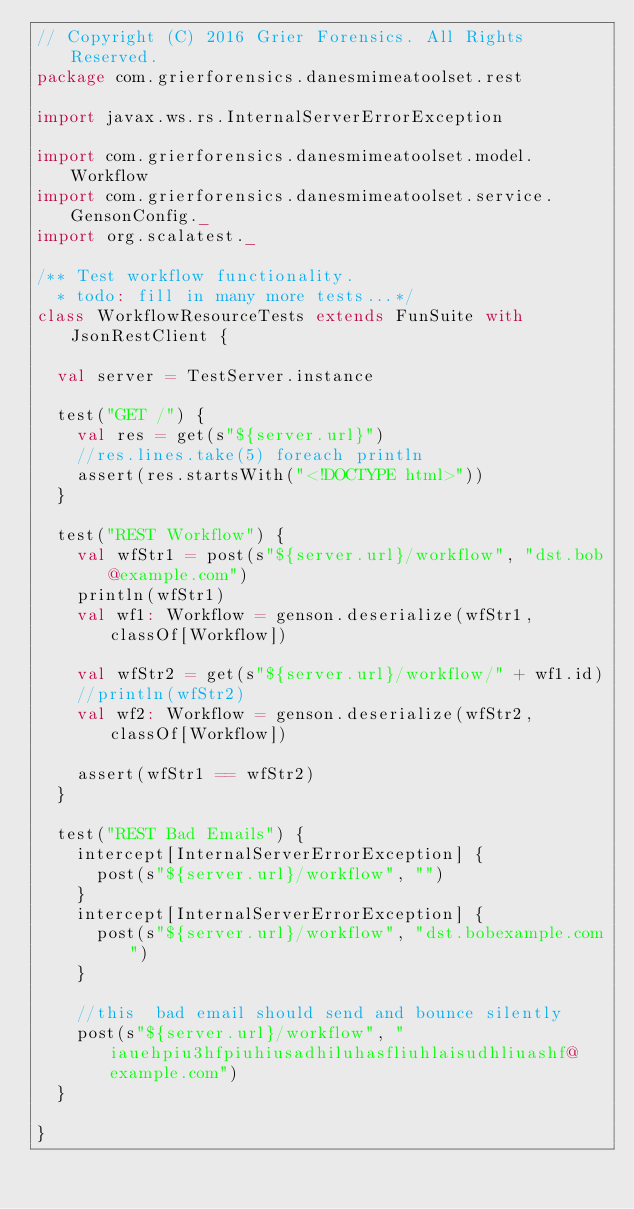<code> <loc_0><loc_0><loc_500><loc_500><_Scala_>// Copyright (C) 2016 Grier Forensics. All Rights Reserved.
package com.grierforensics.danesmimeatoolset.rest

import javax.ws.rs.InternalServerErrorException

import com.grierforensics.danesmimeatoolset.model.Workflow
import com.grierforensics.danesmimeatoolset.service.GensonConfig._
import org.scalatest._

/** Test workflow functionality.
  * todo: fill in many more tests...*/
class WorkflowResourceTests extends FunSuite with JsonRestClient {

  val server = TestServer.instance

  test("GET /") {
    val res = get(s"${server.url}")
    //res.lines.take(5) foreach println
    assert(res.startsWith("<!DOCTYPE html>"))
  }

  test("REST Workflow") {
    val wfStr1 = post(s"${server.url}/workflow", "dst.bob@example.com")
    println(wfStr1)
    val wf1: Workflow = genson.deserialize(wfStr1, classOf[Workflow])

    val wfStr2 = get(s"${server.url}/workflow/" + wf1.id)
    //println(wfStr2)
    val wf2: Workflow = genson.deserialize(wfStr2, classOf[Workflow])

    assert(wfStr1 == wfStr2)
  }

  test("REST Bad Emails") {
    intercept[InternalServerErrorException] {
      post(s"${server.url}/workflow", "")
    }
    intercept[InternalServerErrorException] {
      post(s"${server.url}/workflow", "dst.bobexample.com")
    }

    //this  bad email should send and bounce silently
    post(s"${server.url}/workflow", "iauehpiu3hfpiuhiusadhiluhasfliuhlaisudhliuashf@example.com")
  }

}


</code> 